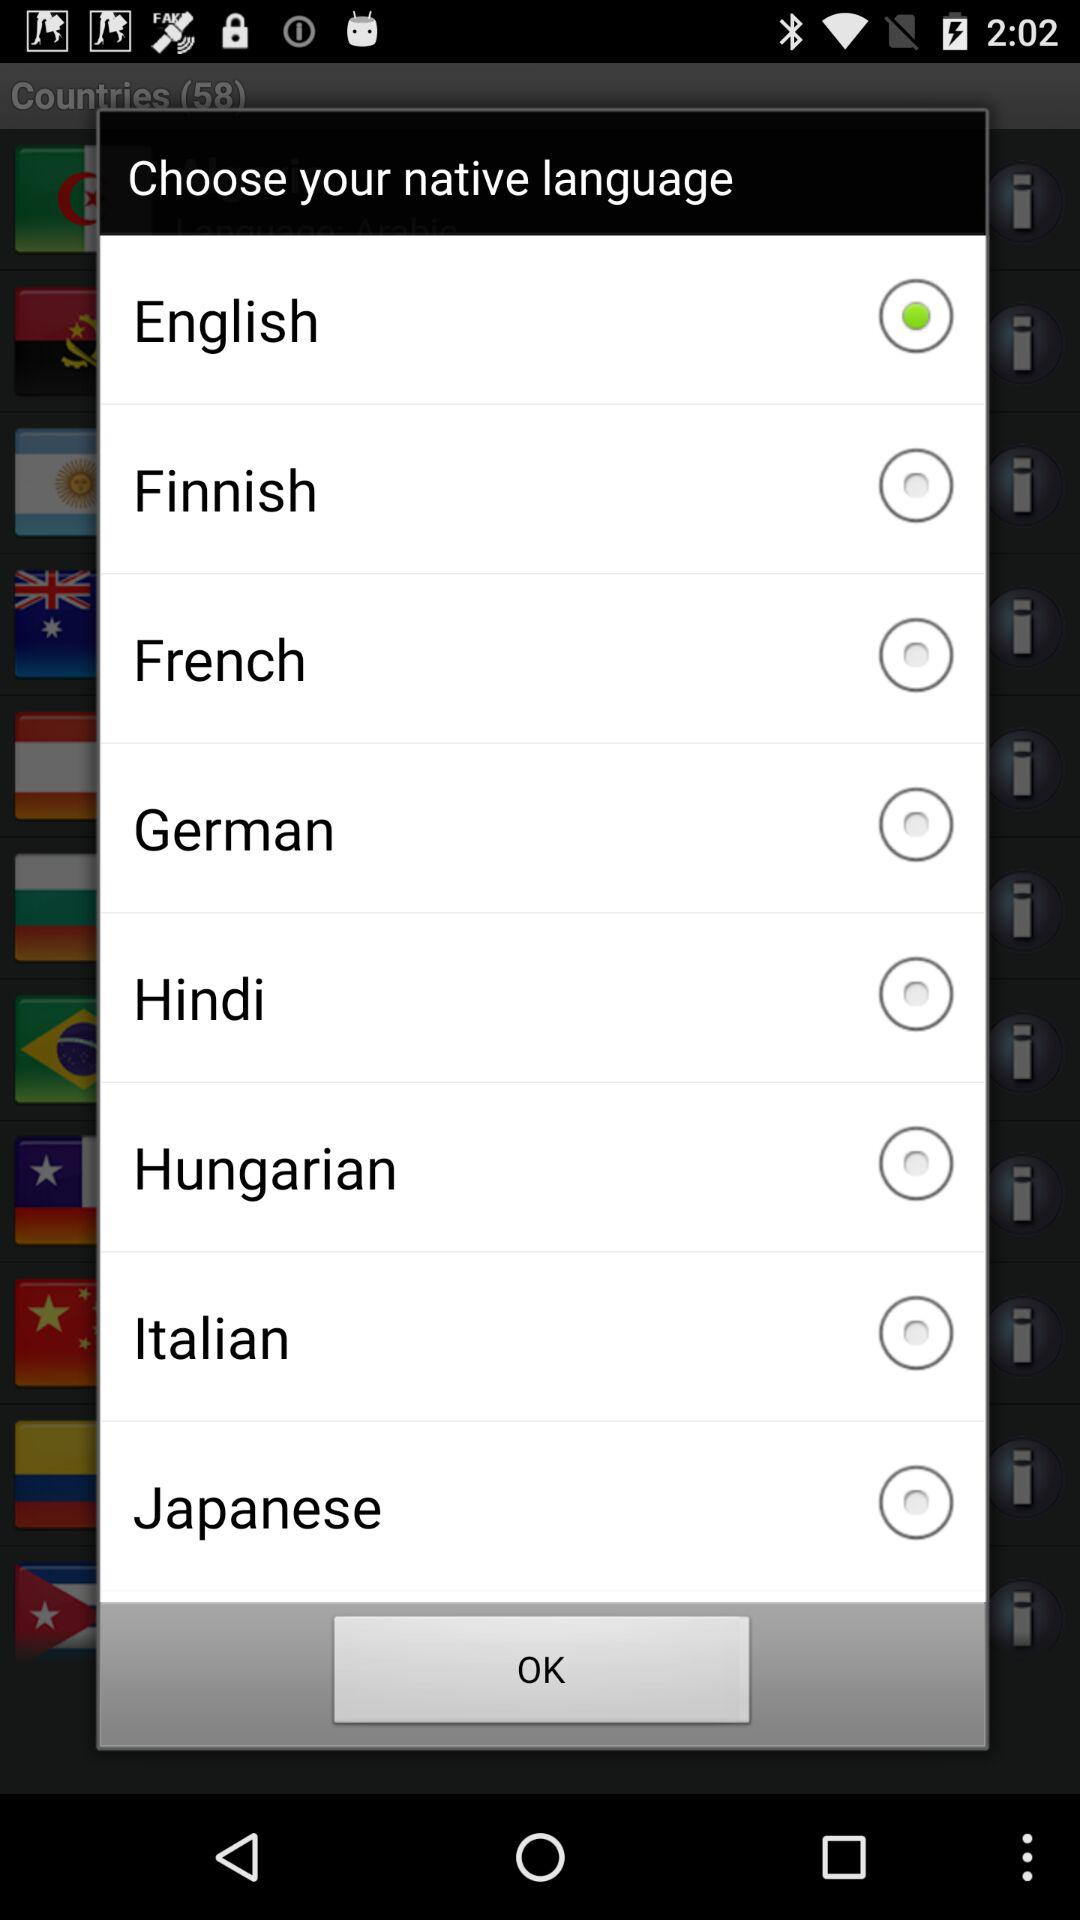Who is this application powered by?
When the provided information is insufficient, respond with <no answer>. <no answer> 